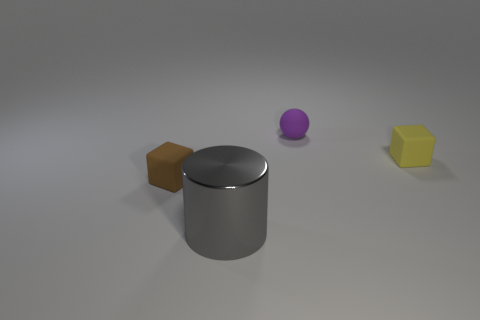Are there any other things that have the same material as the cylinder?
Offer a very short reply. No. Do the yellow block and the gray shiny cylinder have the same size?
Keep it short and to the point. No. Are there any other things that are the same shape as the big thing?
Ensure brevity in your answer.  No. Is the tiny block behind the small brown cube made of the same material as the ball?
Give a very brief answer. Yes. There is a purple ball that is on the left side of the small yellow rubber object; what material is it?
Provide a succinct answer. Rubber. There is a matte block that is left of the tiny cube that is right of the gray metal cylinder; what is its size?
Make the answer very short. Small. How many other gray metallic cylinders are the same size as the metallic cylinder?
Offer a very short reply. 0. There is a yellow block; are there any things left of it?
Provide a succinct answer. Yes. The tiny object that is both in front of the purple matte ball and right of the gray cylinder is what color?
Offer a terse response. Yellow. Are there any cubes that have the same color as the metal thing?
Your answer should be compact. No. 